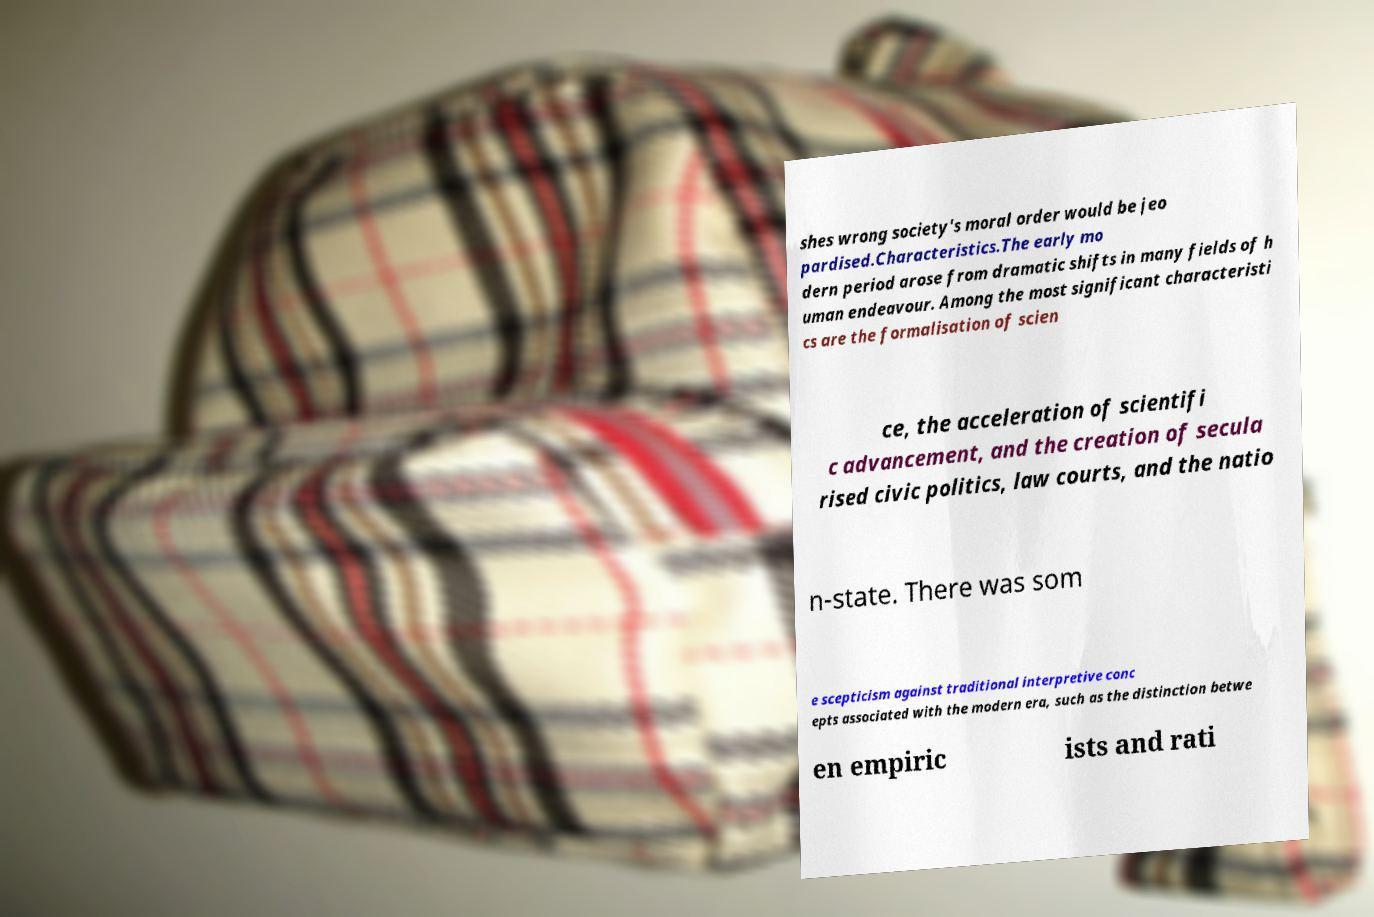Can you read and provide the text displayed in the image?This photo seems to have some interesting text. Can you extract and type it out for me? shes wrong society's moral order would be jeo pardised.Characteristics.The early mo dern period arose from dramatic shifts in many fields of h uman endeavour. Among the most significant characteristi cs are the formalisation of scien ce, the acceleration of scientifi c advancement, and the creation of secula rised civic politics, law courts, and the natio n-state. There was som e scepticism against traditional interpretive conc epts associated with the modern era, such as the distinction betwe en empiric ists and rati 